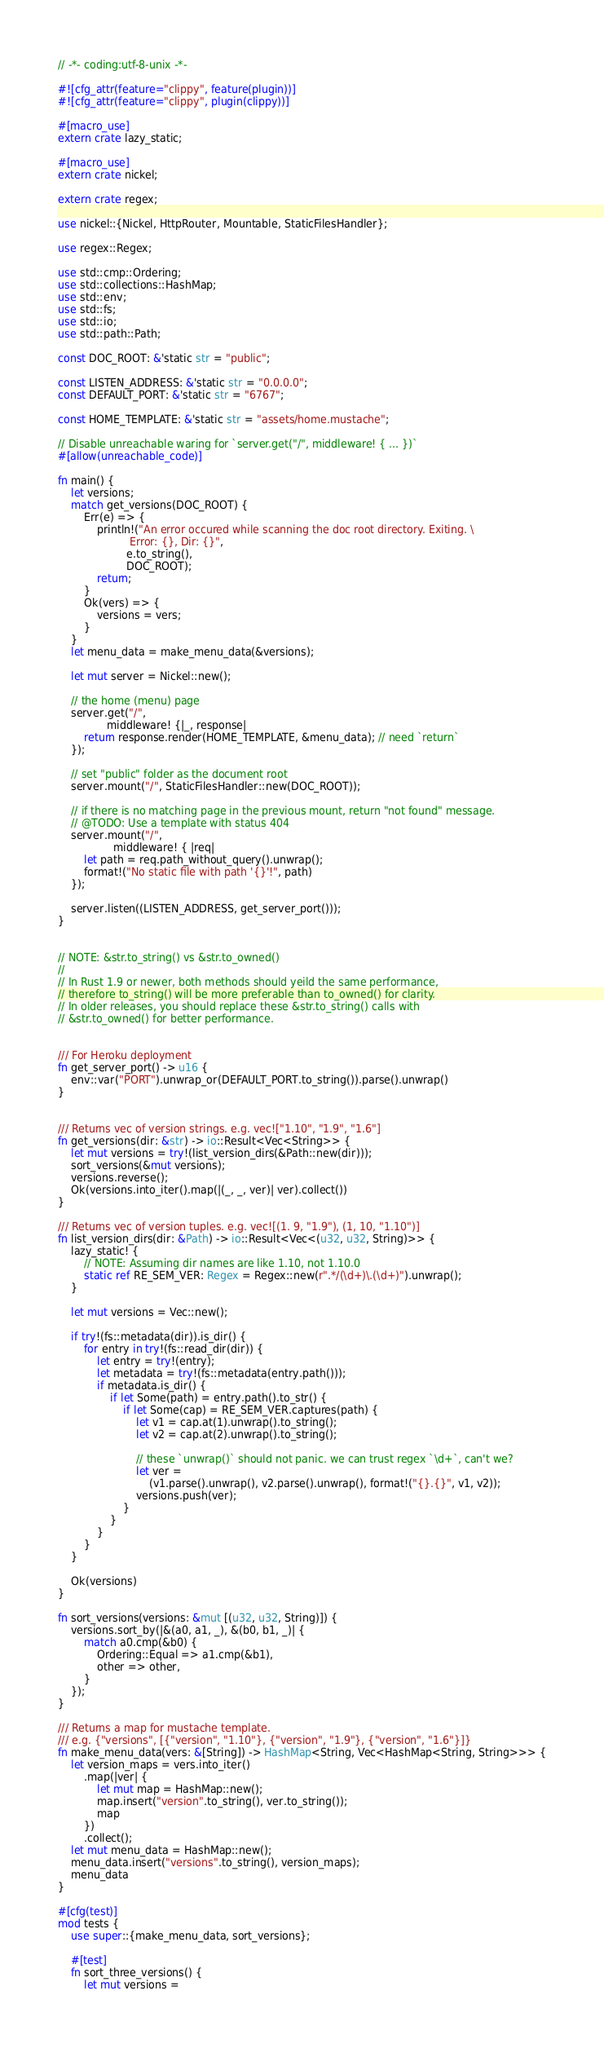Convert code to text. <code><loc_0><loc_0><loc_500><loc_500><_Rust_>// -*- coding:utf-8-unix -*-

#![cfg_attr(feature="clippy", feature(plugin))]
#![cfg_attr(feature="clippy", plugin(clippy))]

#[macro_use]
extern crate lazy_static;

#[macro_use]
extern crate nickel;

extern crate regex;

use nickel::{Nickel, HttpRouter, Mountable, StaticFilesHandler};

use regex::Regex;

use std::cmp::Ordering;
use std::collections::HashMap;
use std::env;
use std::fs;
use std::io;
use std::path::Path;

const DOC_ROOT: &'static str = "public";

const LISTEN_ADDRESS: &'static str = "0.0.0.0";
const DEFAULT_PORT: &'static str = "6767";

const HOME_TEMPLATE: &'static str = "assets/home.mustache";

// Disable unreachable waring for `server.get("/", middleware! { ... })`
#[allow(unreachable_code)]

fn main() {
    let versions;
    match get_versions(DOC_ROOT) {
        Err(e) => {
            println!("An error occured while scanning the doc root directory. Exiting. \
                      Error: {}, Dir: {}",
                     e.to_string(),
                     DOC_ROOT);
            return;
        }
        Ok(vers) => {
            versions = vers;
        }
    }
    let menu_data = make_menu_data(&versions);

    let mut server = Nickel::new();

    // the home (menu) page
    server.get("/",
               middleware! {|_, response|
        return response.render(HOME_TEMPLATE, &menu_data); // need `return`
    });

    // set "public" folder as the document root
    server.mount("/", StaticFilesHandler::new(DOC_ROOT));

    // if there is no matching page in the previous mount, return "not found" message.
    // @TODO: Use a template with status 404
    server.mount("/",
                 middleware! { |req|
        let path = req.path_without_query().unwrap();
        format!("No static file with path '{}'!", path)
    });

    server.listen((LISTEN_ADDRESS, get_server_port()));
}


// NOTE: &str.to_string() vs &str.to_owned()
//
// In Rust 1.9 or newer, both methods should yeild the same performance,
// therefore to_string() will be more preferable than to_owned() for clarity.
// In older releases, you should replace these &str.to_string() calls with
// &str.to_owned() for better performance.


/// For Heroku deployment
fn get_server_port() -> u16 {
    env::var("PORT").unwrap_or(DEFAULT_PORT.to_string()).parse().unwrap()
}


/// Returns vec of version strings. e.g. vec!["1.10", "1.9", "1.6"]
fn get_versions(dir: &str) -> io::Result<Vec<String>> {
    let mut versions = try!(list_version_dirs(&Path::new(dir)));
    sort_versions(&mut versions);
    versions.reverse();
    Ok(versions.into_iter().map(|(_, _, ver)| ver).collect())
}

/// Returns vec of version tuples. e.g. vec![(1. 9, "1.9"), (1, 10, "1.10")]
fn list_version_dirs(dir: &Path) -> io::Result<Vec<(u32, u32, String)>> {
    lazy_static! {
        // NOTE: Assuming dir names are like 1.10, not 1.10.0
        static ref RE_SEM_VER: Regex = Regex::new(r".*/(\d+)\.(\d+)").unwrap();
    }

    let mut versions = Vec::new();

    if try!(fs::metadata(dir)).is_dir() {
        for entry in try!(fs::read_dir(dir)) {
            let entry = try!(entry);
            let metadata = try!(fs::metadata(entry.path()));
            if metadata.is_dir() {
                if let Some(path) = entry.path().to_str() {
                    if let Some(cap) = RE_SEM_VER.captures(path) {
                        let v1 = cap.at(1).unwrap().to_string();
                        let v2 = cap.at(2).unwrap().to_string();

                        // these `unwrap()` should not panic. we can trust regex `\d+`, can't we?
                        let ver =
                            (v1.parse().unwrap(), v2.parse().unwrap(), format!("{}.{}", v1, v2));
                        versions.push(ver);
                    }
                }
            }
        }
    }

    Ok(versions)
}

fn sort_versions(versions: &mut [(u32, u32, String)]) {
    versions.sort_by(|&(a0, a1, _), &(b0, b1, _)| {
        match a0.cmp(&b0) {
            Ordering::Equal => a1.cmp(&b1),
            other => other,
        }
    });
}

/// Returns a map for mustache template.
/// e.g. {"versions", [{"version", "1.10"}, {"version", "1.9"}, {"version", "1.6"}]}
fn make_menu_data(vers: &[String]) -> HashMap<String, Vec<HashMap<String, String>>> {
    let version_maps = vers.into_iter()
        .map(|ver| {
            let mut map = HashMap::new();
            map.insert("version".to_string(), ver.to_string());
            map
        })
        .collect();
    let mut menu_data = HashMap::new();
    menu_data.insert("versions".to_string(), version_maps);
    menu_data
}

#[cfg(test)]
mod tests {
    use super::{make_menu_data, sort_versions};

    #[test]
    fn sort_three_versions() {
        let mut versions =</code> 